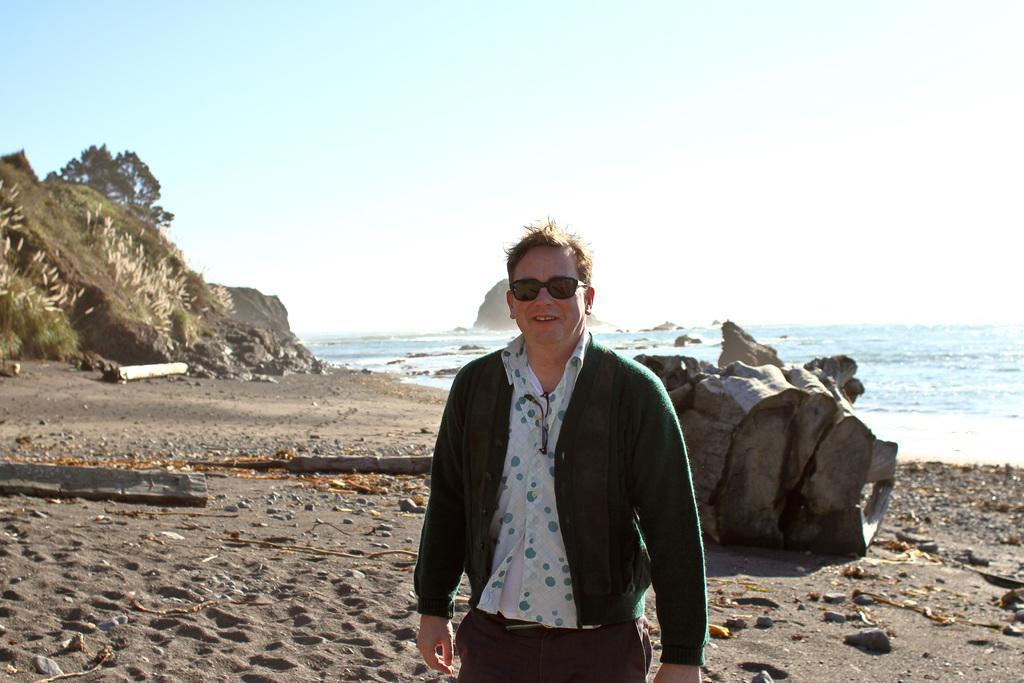Can you describe this image briefly? In the middle of the image, there is a person in a jacket, smiling and standing. In the background, there are woods on the sand surface, there is an ocean, there is a mountain and there are clouds in the sky. 